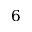<formula> <loc_0><loc_0><loc_500><loc_500>6</formula> 